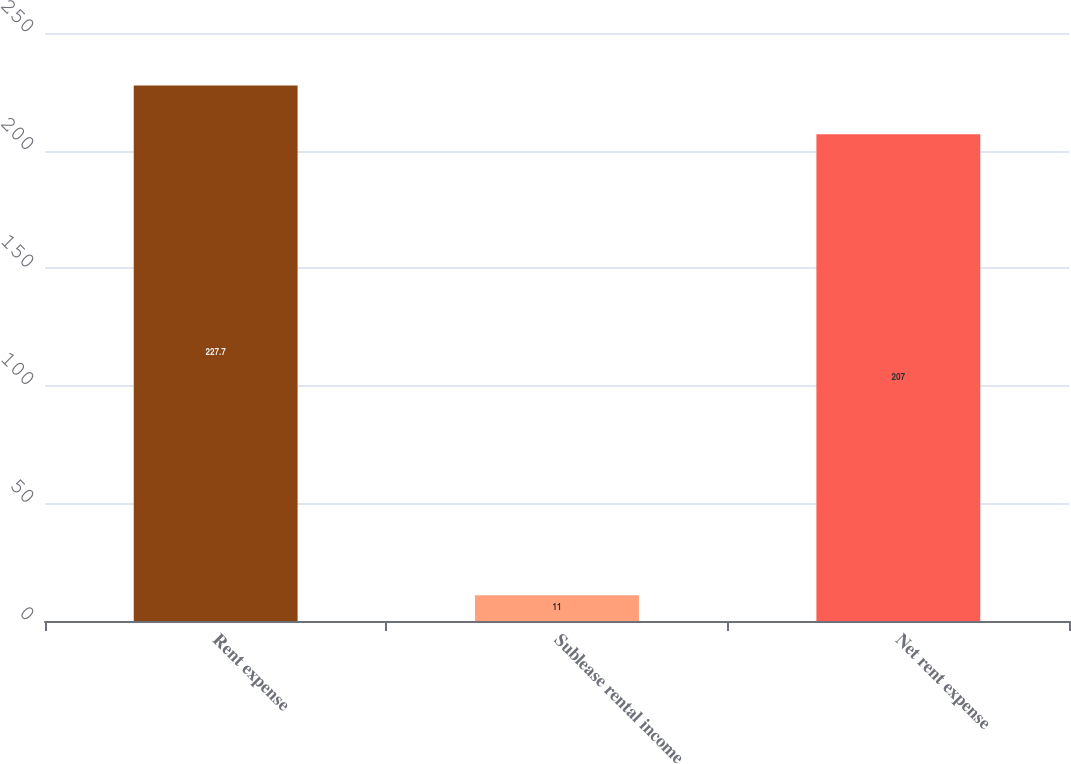Convert chart to OTSL. <chart><loc_0><loc_0><loc_500><loc_500><bar_chart><fcel>Rent expense<fcel>Sublease rental income<fcel>Net rent expense<nl><fcel>227.7<fcel>11<fcel>207<nl></chart> 